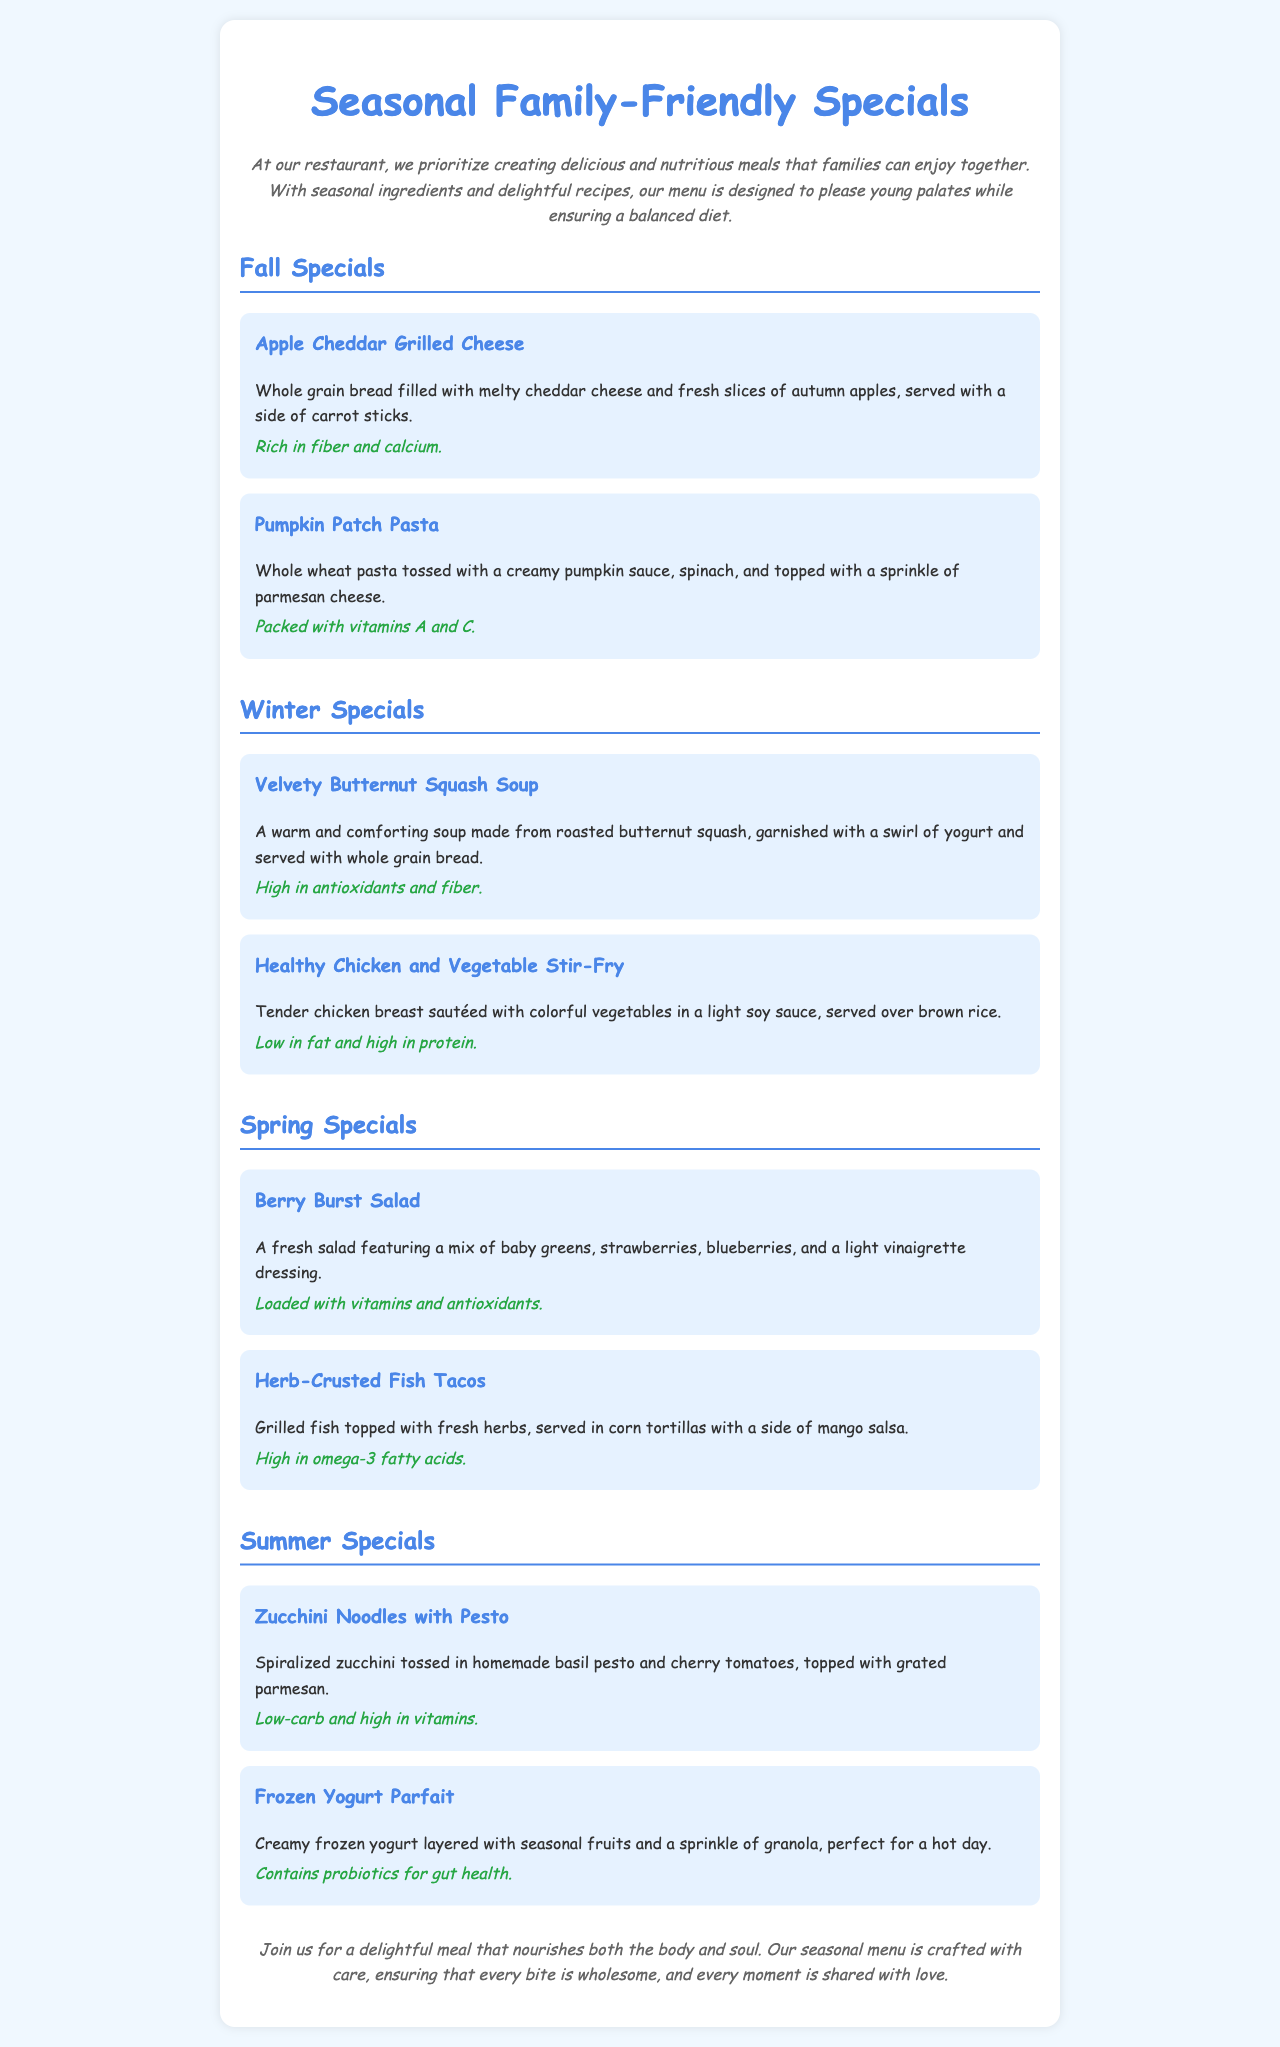What are the Fall specials? The document lists the Fall specials as "Apple Cheddar Grilled Cheese" and "Pumpkin Patch Pasta."
Answer: Apple Cheddar Grilled Cheese, Pumpkin Patch Pasta What is the main ingredient in the "Berry Burst Salad"? The description of the "Berry Burst Salad" mentions a mix of baby greens and berries.
Answer: Baby greens, strawberries, blueberries What are the nutritional benefits of the "Velvety Butternut Squash Soup"? The document states that it is high in antioxidants and fiber.
Answer: High in antioxidants and fiber Which season features "Zucchini Noodles with Pesto"? The menu categorizes "Zucchini Noodles with Pesto" under the Summer specials.
Answer: Summer What is served with the "Herb-Crusted Fish Tacos"? The document describes it being served with a side of mango salsa.
Answer: Mango salsa How many dishes are offered in the Winter specials? The Winter specials section contains two dishes: "Velvety Butternut Squash Soup" and "Healthy Chicken and Vegetable Stir-Fry."
Answer: 2 